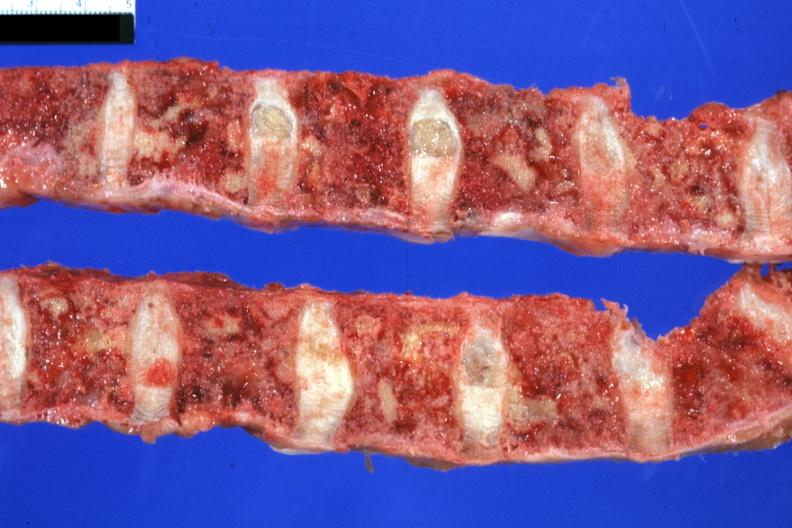does this image show vertebral column with multiple lesions easily seen colon primary?
Answer the question using a single word or phrase. Yes 